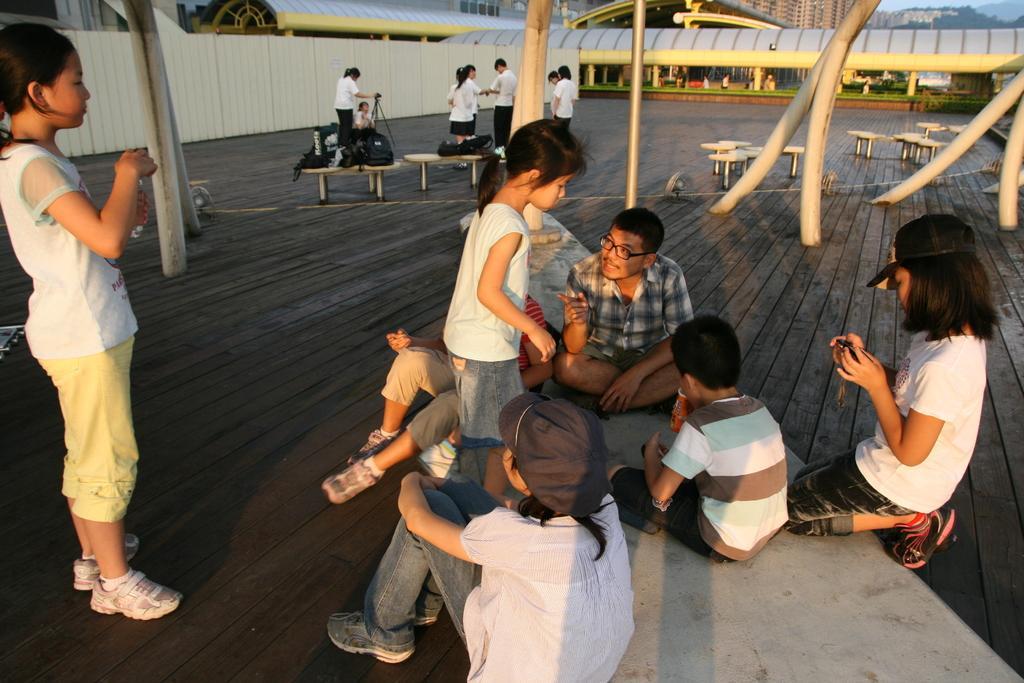In one or two sentences, can you explain what this image depicts? In this image, there are a few people. We can see the ground and some poles. We can also see some benches. Among them, we can see some benches with objects. We can see the sheds. We can see the wall. There are a few buildings and trees. We can also see the sky. 